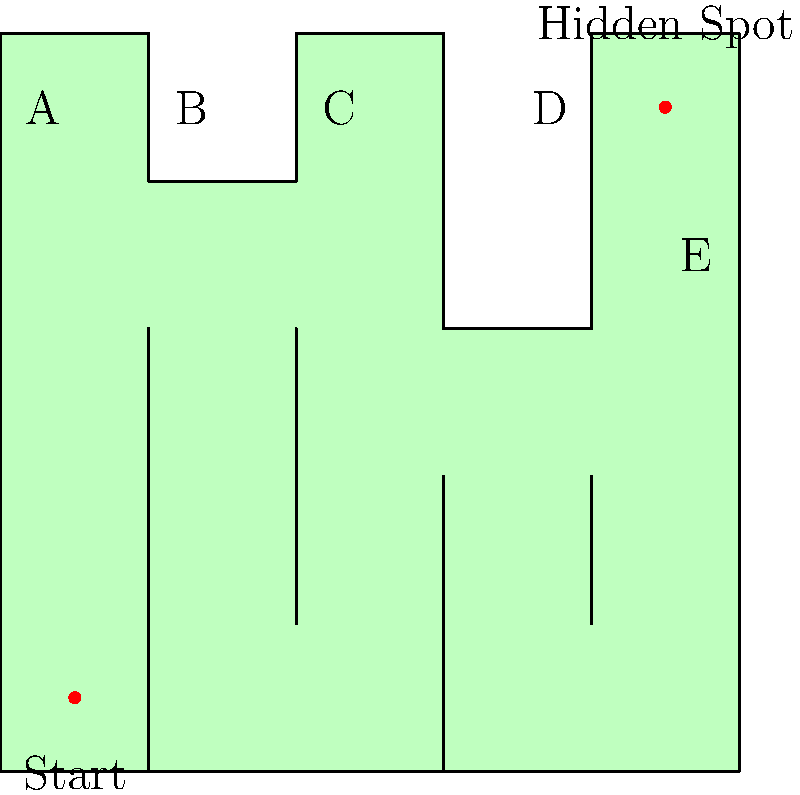Navigate through the charming French village maze to find the hidden romantic spot. Starting from the bottom left, what is the correct sequence of labeled points to reach the destination? Let's navigate the maze step-by-step:

1. Begin at the start point in the bottom left corner.
2. Move upwards until you reach point A.
3. From A, move right to point B.
4. Continue moving right to point C.
5. From C, move downwards and then right to reach point D.
6. Finally, move upwards from D to reach point E.
7. From E, move upwards to reach the hidden romantic spot.

The correct sequence of labeled points is A, B, C, D, and E.
Answer: A, B, C, D, E 